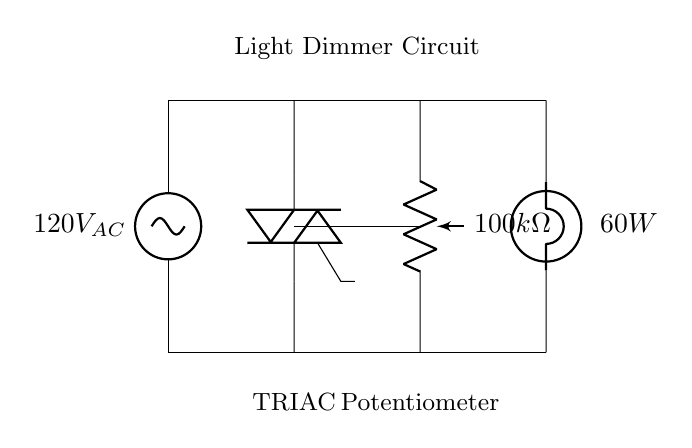What is the voltage of this circuit? The circuit diagram indicates that the source voltage is labeled as 120V AC, which means the circuit is designed to operate at that potential difference.
Answer: 120V AC What type of TRIAC is used? The circuit diagram does not specify a particular model or type of TRIAC, but it depicts a generic TRIAC symbol which is commonly used in dimmer circuits for controlling AC loads.
Answer: TRIAC What is the resistance value of the potentiometer? The potentiometer in the circuit is labeled as having a resistance of 100k ohms, indicating its role in varying the light output by adjusting the current flow through the circuit.
Answer: 100k ohms How does the potentiometer affect the light bulb? The potentiometer controls the amount of current flowing to the light bulb; as it is adjusted, it changes the effective resistance in the circuit, which in turn varies the brightness of the bulb.
Answer: Brightness control What is the power rating of the light bulb? The light bulb shown in the circuit is labeled as 60 watts, indicating the maximum power it can handle under normal operation.
Answer: 60 watts Explain how the TRIAC functions in this circuit. The TRIAC functions as a switch that can control the power delivered to the light bulb; when triggered, it allows current to flow during each AC cycle, effectively chopping the waveform and reducing the average power delivered, thus dimming the light.
Answer: Power control What is the purpose of the light dimmer circuit? The primary purpose of the light dimmer circuit is to regulate the brightness of the light bulb by adjusting the voltage and current flowing through it, providing energy savings and customization for ambiance.
Answer: Brightness regulation 